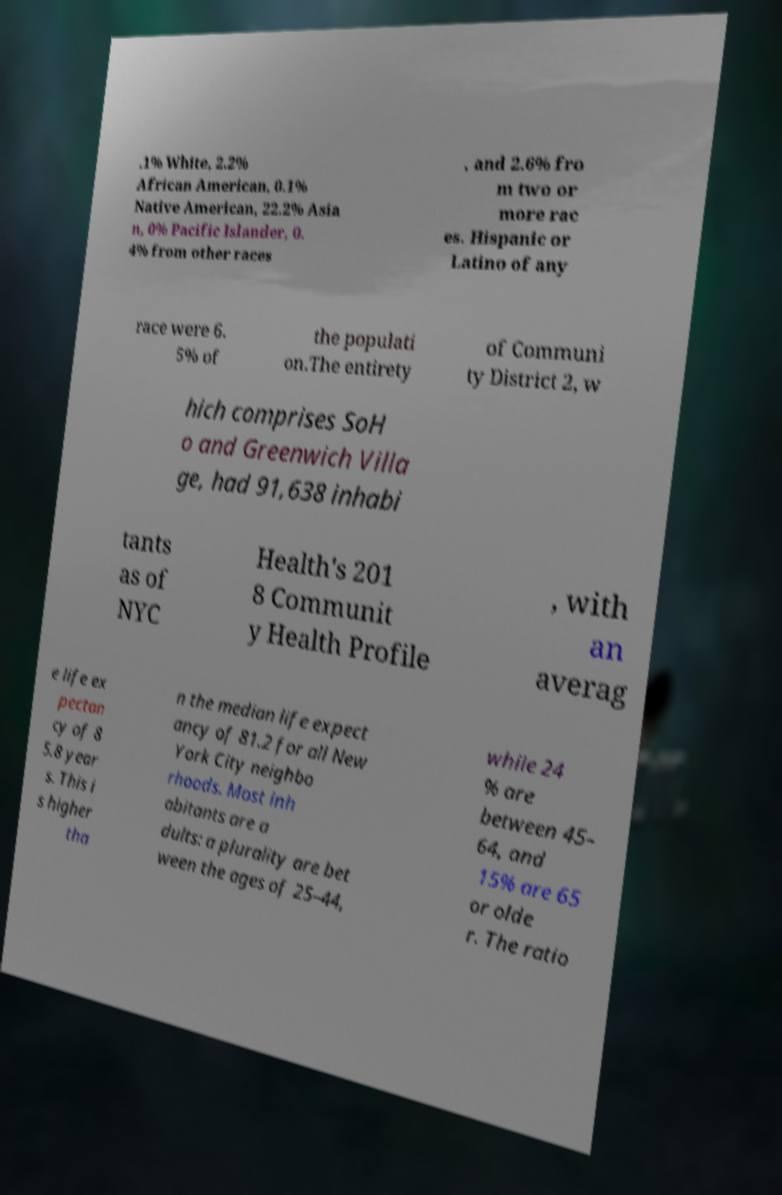Please read and relay the text visible in this image. What does it say? .1% White, 2.2% African American, 0.1% Native American, 22.2% Asia n, 0% Pacific Islander, 0. 4% from other races , and 2.6% fro m two or more rac es. Hispanic or Latino of any race were 6. 5% of the populati on.The entirety of Communi ty District 2, w hich comprises SoH o and Greenwich Villa ge, had 91,638 inhabi tants as of NYC Health's 201 8 Communit y Health Profile , with an averag e life ex pectan cy of 8 5.8 year s. This i s higher tha n the median life expect ancy of 81.2 for all New York City neighbo rhoods. Most inh abitants are a dults: a plurality are bet ween the ages of 25–44, while 24 % are between 45– 64, and 15% are 65 or olde r. The ratio 